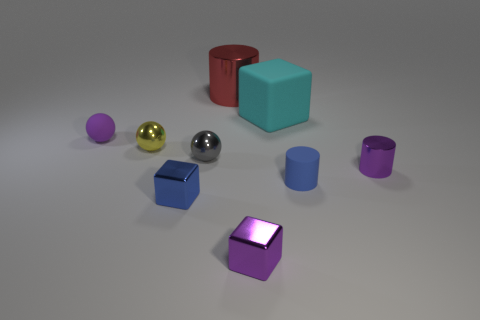Add 1 cylinders. How many objects exist? 10 Subtract all cylinders. How many objects are left? 6 Subtract 0 red spheres. How many objects are left? 9 Subtract all small blue cubes. Subtract all tiny spheres. How many objects are left? 5 Add 4 big shiny objects. How many big shiny objects are left? 5 Add 7 small purple objects. How many small purple objects exist? 10 